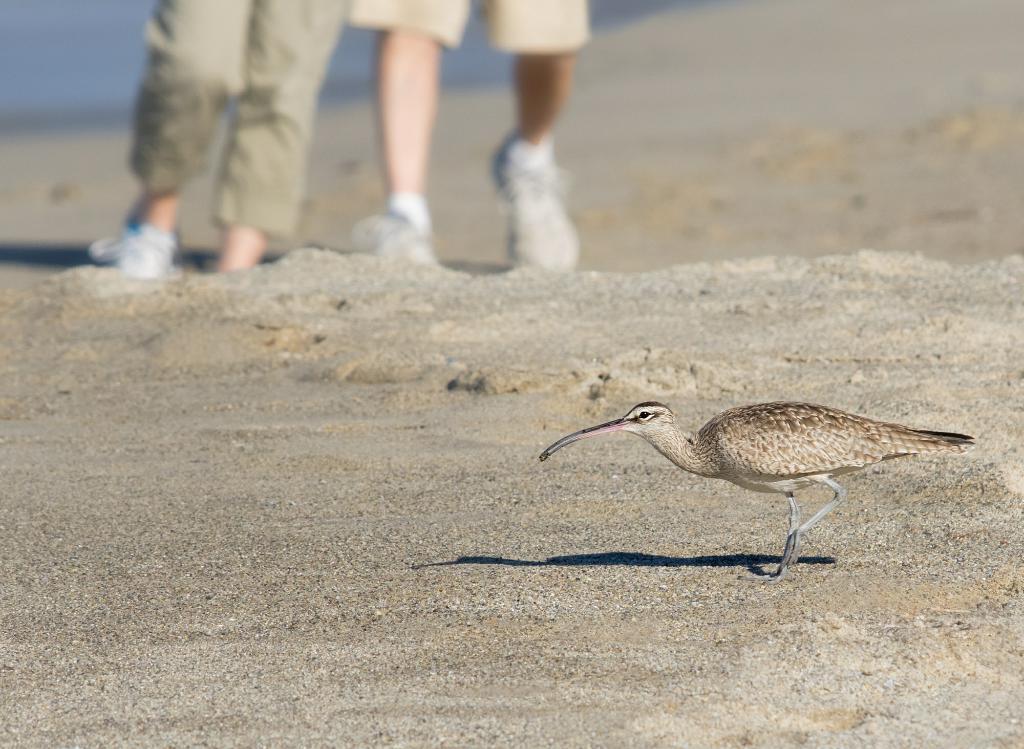In one or two sentences, can you explain what this image depicts? In the foreground of this image, there is a bird on the sand. At the top, there are legs of a person. 